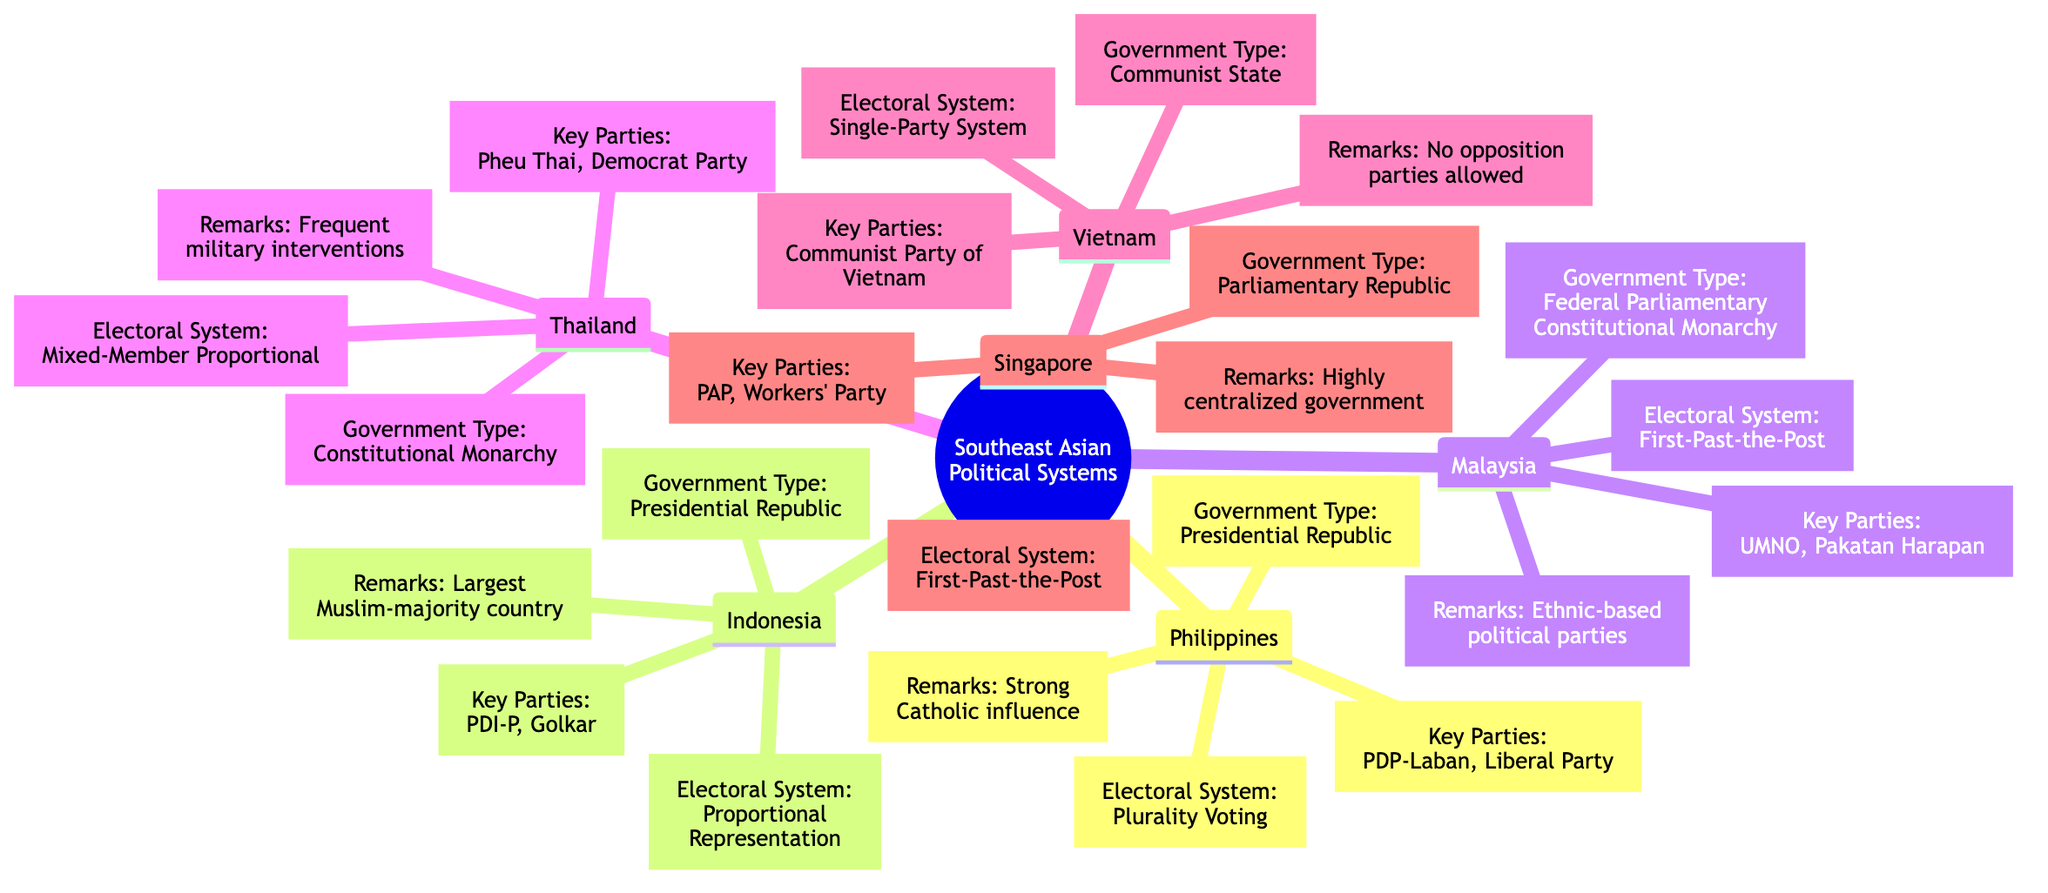What is the government type of the Philippines? The diagram indicates that the government type of the Philippines is a "Presidential Republic". This information is specifically stated under the node for the Philippines.
Answer: Presidential Republic How many key political parties are listed for Indonesia? Under the Indonesia node, there are two key political parties mentioned: "PDI-P" and "Golkar". The count of parties can easily be observed as two.
Answer: 2 What electoral system does Malaysia use? The electoral system for Malaysia is identified in the node as "First-Past-the-Post". This is a standard term for describing their electoral process.
Answer: First-Past-the-Post Which country listed has a single-party system? The diagram indicates that Vietnam is the country with a "Single-Party System". This specific characteristic is mentioned in the Vietnam node.
Answer: Vietnam What is a notable remark about Indonesia? The node for Indonesia contains a remark stating, "Largest Muslim-majority country". This highlights an important aspect of Indonesia's demographic and cultural identity.
Answer: Largest Muslim-majority country Which electoral systems are used by Malaysia and Singapore? Malaysia uses "First-Past-the-Post" and Singapore also uses "First-Past-the-Post" as its electoral system. The information is located in their respective nodes, and both electoral systems are the same.
Answer: First-Past-the-Post What type of government does Thailand have? Thailand is classified as a "Constitutional Monarchy". This designation is clearly stated in the node associated with Thailand.
Answer: Constitutional Monarchy How does the political structure of Vietnam differ from that of the Philippines? Vietnam is noted as a "Communist State" with a "Single-Party System", while the Philippines is a "Presidential Republic" with multiple key political parties. This highlights the fundamental difference in governance models.
Answer: Different governance models Which country has frequent military interventions as a key point? The key point regarding frequent military interventions is specifically mentioned under the Thailand node. This distinguishes Thailand's political landscape from others in the diagram.
Answer: Thailand 